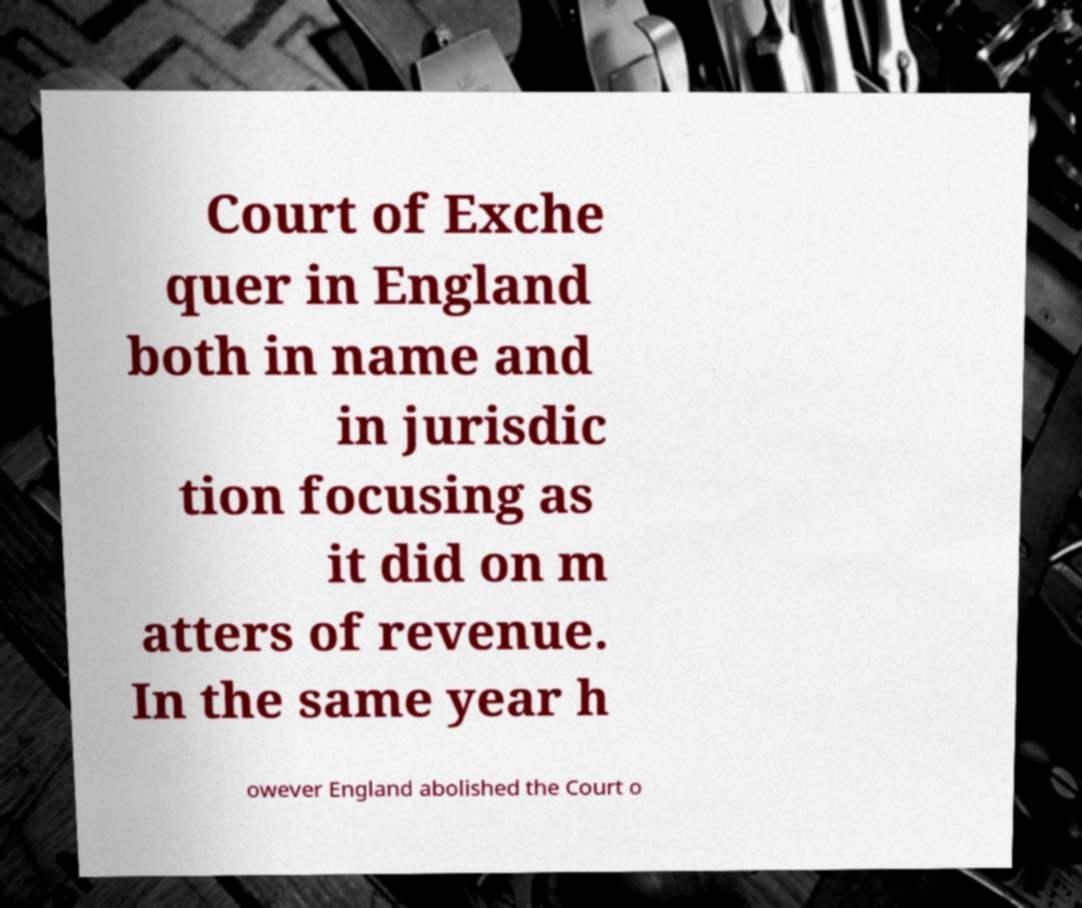I need the written content from this picture converted into text. Can you do that? Court of Exche quer in England both in name and in jurisdic tion focusing as it did on m atters of revenue. In the same year h owever England abolished the Court o 